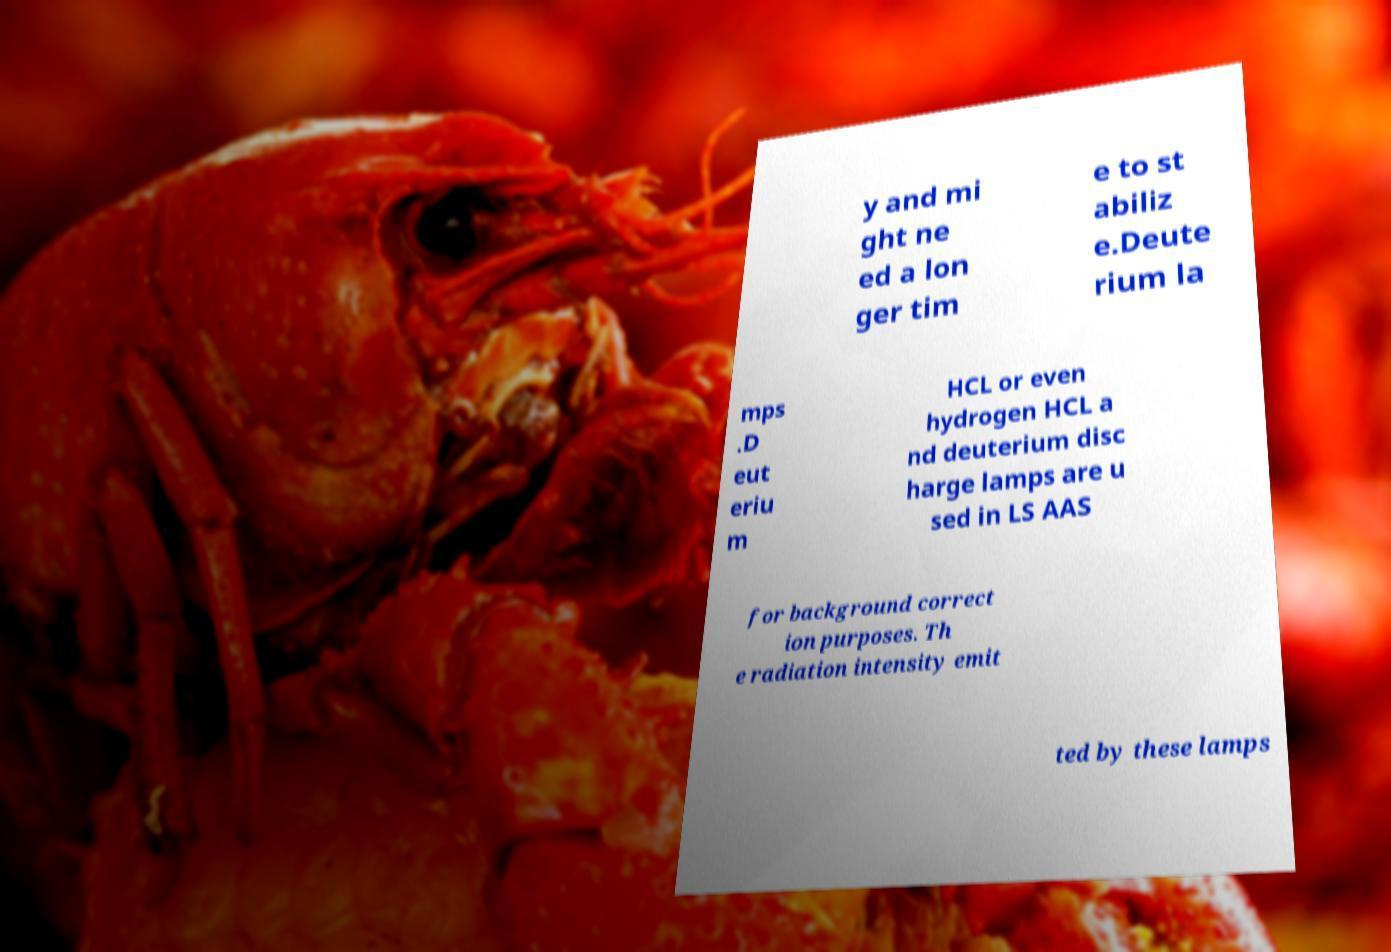Please identify and transcribe the text found in this image. y and mi ght ne ed a lon ger tim e to st abiliz e.Deute rium la mps .D eut eriu m HCL or even hydrogen HCL a nd deuterium disc harge lamps are u sed in LS AAS for background correct ion purposes. Th e radiation intensity emit ted by these lamps 